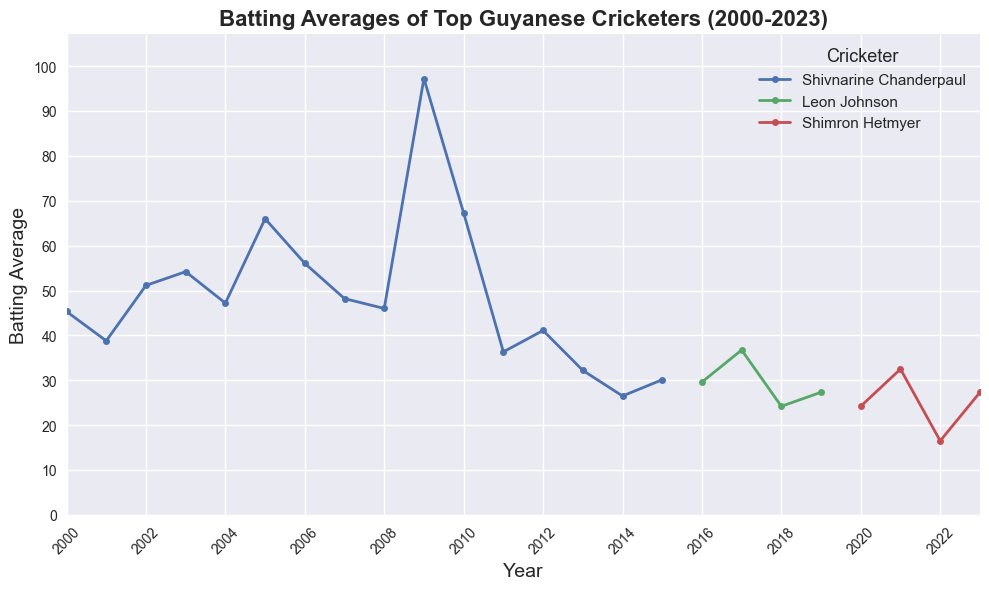What year did Shivnarine Chanderpaul achieve his highest batting average? Observe Shivnarine Chanderpaul's line in the plot and identify the peak point. His highest average was in 2009.
Answer: 2009 Whose batting average improved the most from their initial year to their peak year? Compare the increase for each cricketer. Chanderpaul’s batting average increased from 45.33 in 2000 to 97.25 in 2009, while Johnson and Hetmyer had smaller improvements.
Answer: Shivnarine Chanderpaul Between 2008 and 2010, how did Shivnarine Chanderpaul's batting average change? Locate Shivnarine Chanderpaul’s data points for 2008 (46.00), 2009 (97.25), and 2010 (67.27) and observe the trend. The batting average initially increased to 97.25 in 2009 before decreasing to 67.27 in 2010.
Answer: It increased between 2008 and 2009, then decreased in 2010 Compare Shimron Hetmyer's batting averages in 2020 and 2022. Look at Shimron Hetmyer's plot points for 2020 (24.22) and 2022 (16.50) to note the comparison.
Answer: 2022 is lesser than 2020 Which cricketer had the lowest recorded batting average and in what year? Identify the lowest point in the plot and match it to the cricketer and year. Shimron Hetmyer had the lowest average of 16.50 in 2022.
Answer: Shimron Hetmyer in 2022 How did Leon Johnson’s batting average change from 2016 to 2019? Trace the line for Leon Johnson from 2016 (29.60) to 2019 (27.33). His average slightly fluctuated but had an overall slight decrease.
Answer: It slightly decreased Which cricketer maintained above a 50 batting average for the longest period? Identify which cricketer's line stays above the 50 mark the longest. Shivnarine Chanderpaul stayed above 50 from 2002 to 2010, so for eight years.
Answer: Shivnarine Chanderpaul What is the difference in batting average between Shivnarine Chanderpaul's lowest and highest years? Calculate the difference between his highest (97.25 in 2009) and lowest (26.50 in 2014) batting averages. 97.25 - 26.50 = 70.75.
Answer: 70.75 Which year did all three cricketers have distinct averages without overlap? Look for a year where each cricketer has a different plot point. In 2000 and 2016 onward only Leon Johnson and Shimron Hetmyer are present. A more detailed year review shows 2016 where they all recorded distinct averages.
Answer: 2016 Who's batting average saw the most fluctuation through the years? Determine the cricketer with the most variability by visually inspecting the lines. Shivnarine Chanderpaul’s line shows the most fluctuation.
Answer: Shivnarine Chanderpaul 